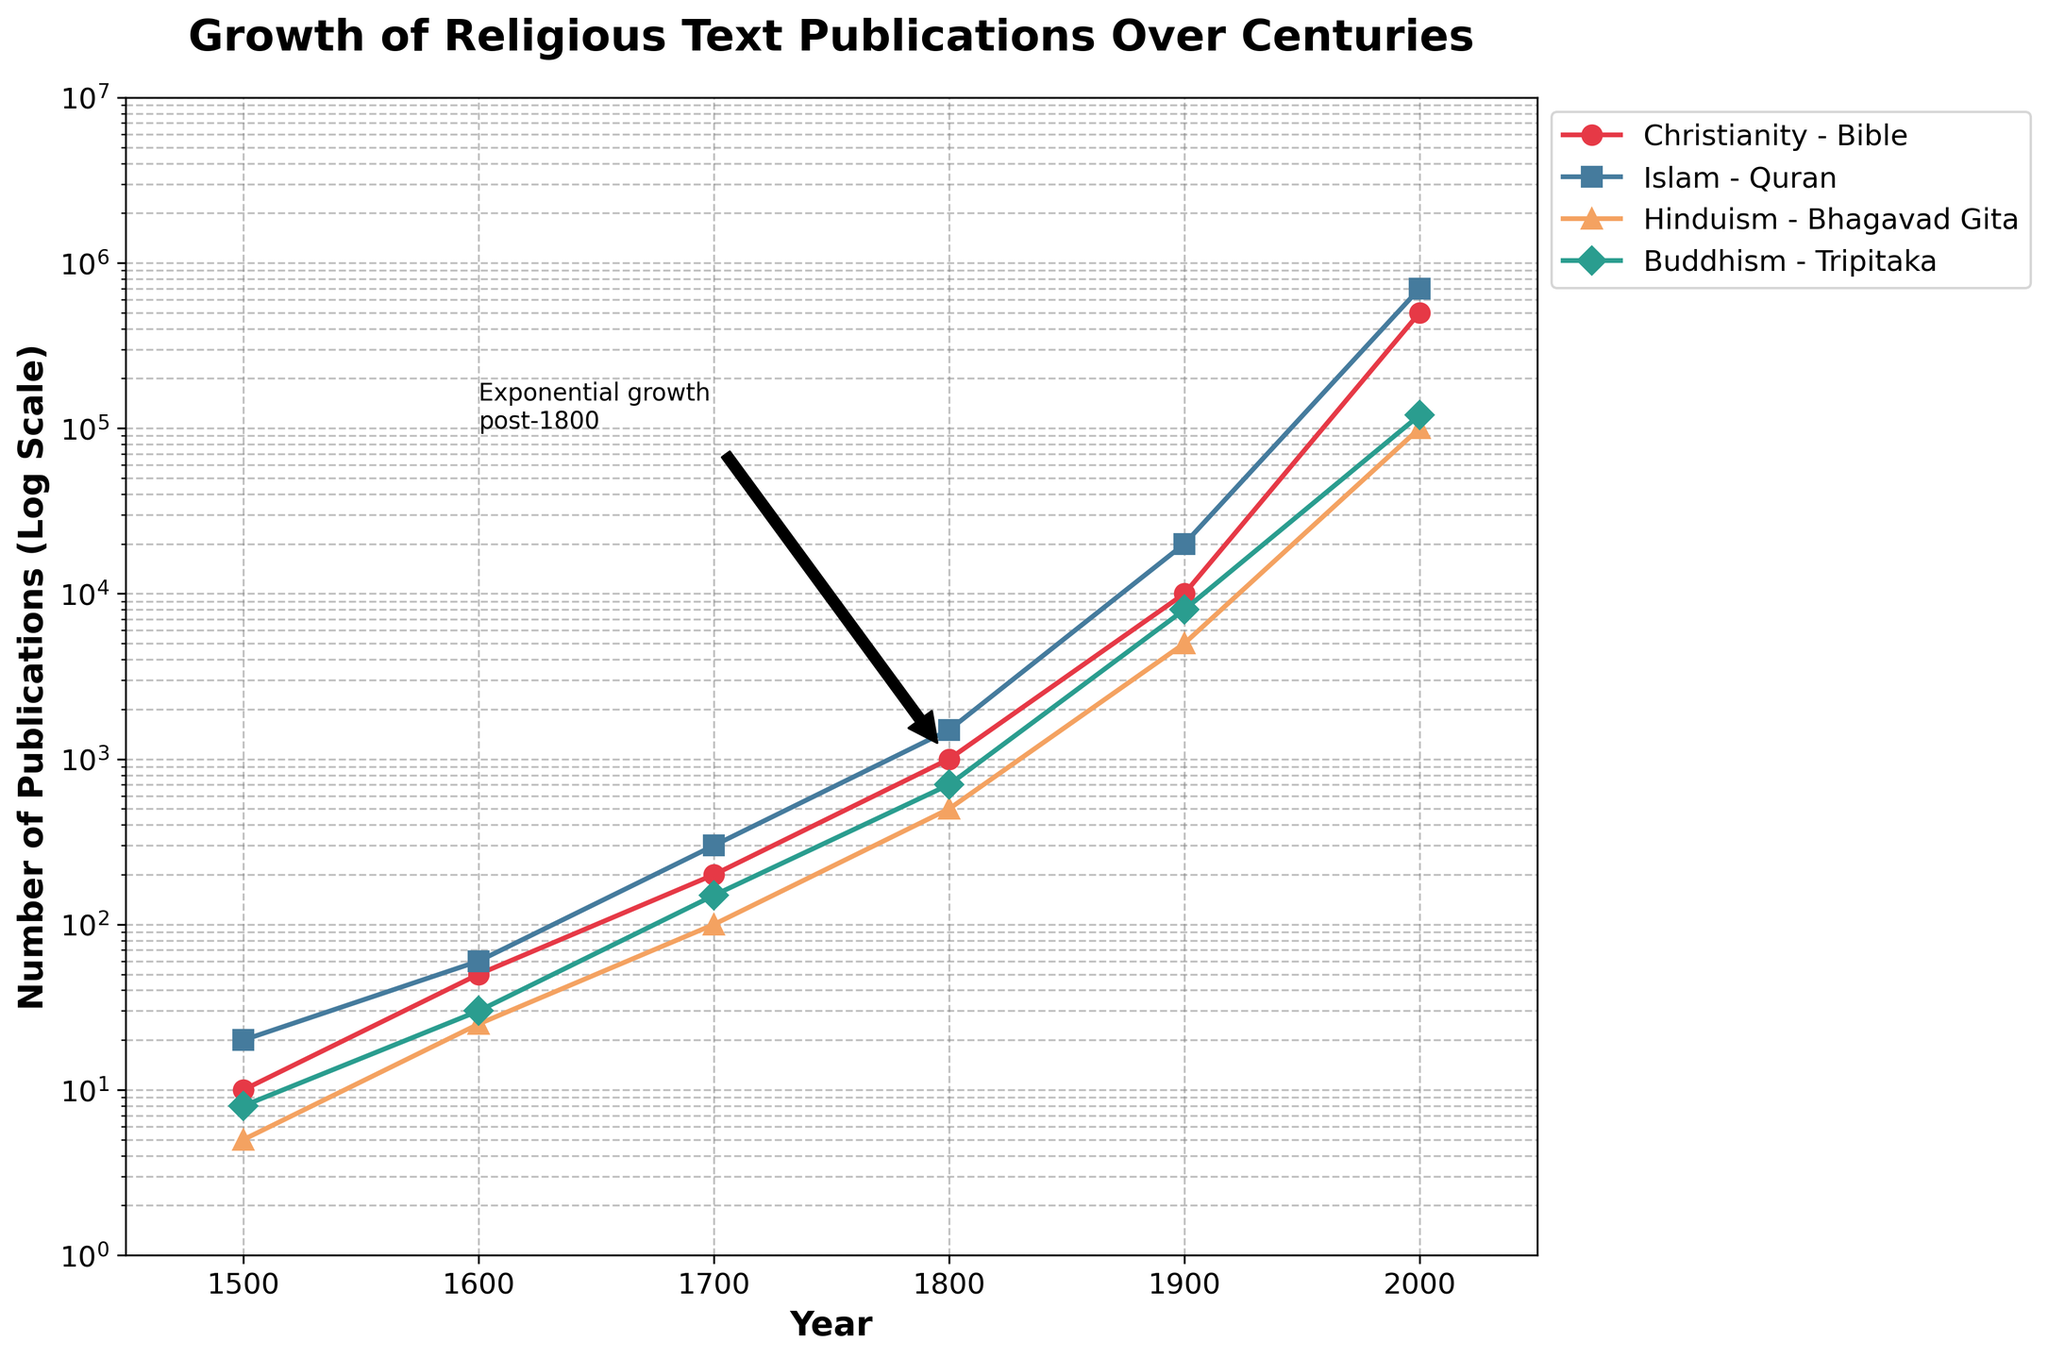What's the title of the plot? The title of the plot is displayed at the top of the figure in bold and large fonts, which is 'Growth of Religious Text Publications Over Centuries'.
Answer: Growth of Religious Text Publications Over Centuries Which religious text had the highest number of publications in the year 2000? By observing the plot, we notice that in the year 2000, the line for Islam - Quran reaches the highest value on the y-axis, surpassing all other religious texts.
Answer: Islam - Quran How does the publication growth rate of the Bible compare to the Bhagavad Gita between 1800 and 1900? Between 1800 and 1900, the number of Bible publications grew from 1000 to 10,000, a 10-fold increase, whereas the Bhagavad Gita grew from 500 to 5,000, also a 10-fold increase. Thus, their growth rates were similar in this period.
Answer: Similar What is the trend of publication growth for all religious texts post-1800? Observing the annotated part of the plot, all religious texts show a steep exponential growth after 1800, marked by the rising lines on the log scale.
Answer: Exponential growth In which century did the publication of the Bible exceed 10,000? The plot shows that the publication count of the Bible crosses the 10,000 mark around the year 1900.
Answer: 20th century Which religion shows the earliest onset of a significant increase in publication volume? By inspecting the steepness and timing of the lines on the plot, Christianity (Bible) shows a significant increase earlier, noticeable from 1700 onwards compared to other religions.
Answer: Christianity Between the years 1500 and 2000, which text experienced the least amount of growth in publications? Comparing the start and end points of the lines on the plot from 1500 to 2000, the Hinduism (Bhagavad Gita) line shows the least growth compared to others.
Answer: Bhagavad Gita What is the approximate number of Quran publications around the year 1900? Referring to the plot, around the 1900 mark, the line for Islam (Quran) is positioned near the 20,000 value on the y-axis.
Answer: 20,000 How does the growth in publication numbers of the Tripitaka compare to that of the Bhagavad Gita between 1700 and 2000? Between 1700 and 2000, the Tripitaka grew from 150 to 120,000, while the Bhagavad Gita grew from 100 to 100,000. The growth rate of the Tripitaka is slightly higher.
Answer: Slightly higher Is the growth of publication of religious texts generally similar across different religions? The plot shows all religions have a similar pattern of exponential growth after 1800, though the exact rates and starting points differ. Hence, the general trend is similar.
Answer: Yes 